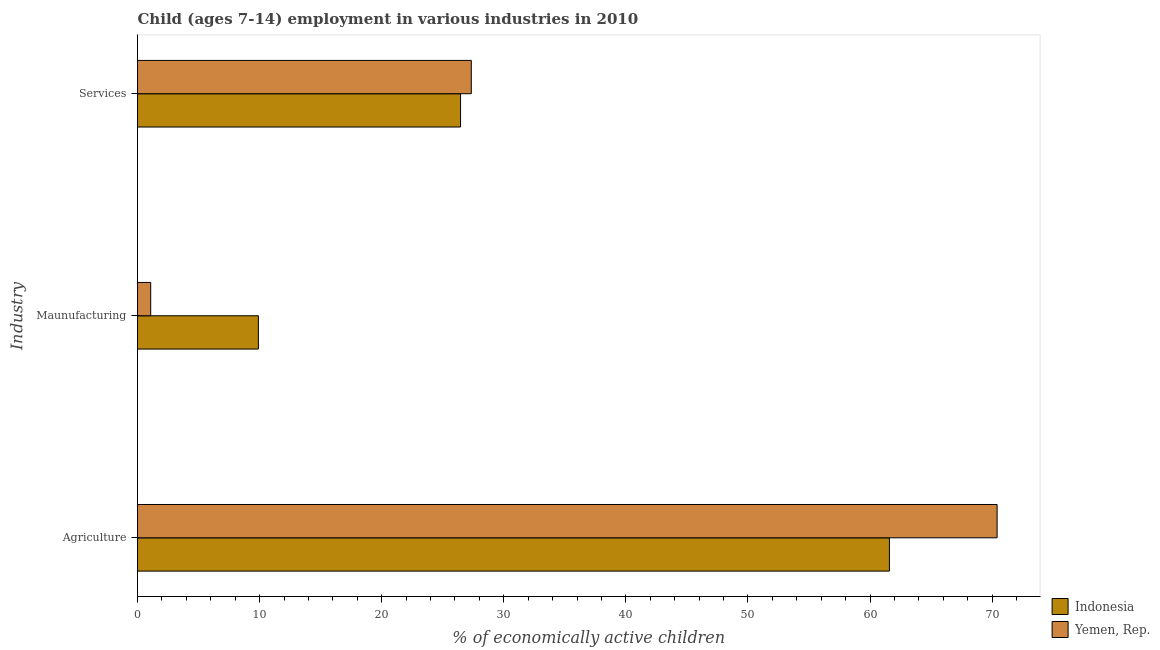How many different coloured bars are there?
Your answer should be compact. 2. How many groups of bars are there?
Provide a succinct answer. 3. Are the number of bars on each tick of the Y-axis equal?
Make the answer very short. Yes. How many bars are there on the 3rd tick from the bottom?
Provide a short and direct response. 2. What is the label of the 2nd group of bars from the top?
Offer a terse response. Maunufacturing. What is the percentage of economically active children in services in Yemen, Rep.?
Provide a succinct answer. 27.34. Across all countries, what is the maximum percentage of economically active children in agriculture?
Your answer should be compact. 70.41. Across all countries, what is the minimum percentage of economically active children in agriculture?
Make the answer very short. 61.59. In which country was the percentage of economically active children in manufacturing maximum?
Provide a short and direct response. Indonesia. In which country was the percentage of economically active children in agriculture minimum?
Give a very brief answer. Indonesia. What is the total percentage of economically active children in agriculture in the graph?
Make the answer very short. 132. What is the difference between the percentage of economically active children in agriculture in Yemen, Rep. and that in Indonesia?
Make the answer very short. 8.82. What is the difference between the percentage of economically active children in agriculture in Yemen, Rep. and the percentage of economically active children in manufacturing in Indonesia?
Ensure brevity in your answer.  60.51. What is the difference between the percentage of economically active children in manufacturing and percentage of economically active children in services in Indonesia?
Provide a succinct answer. -16.56. In how many countries, is the percentage of economically active children in agriculture greater than 4 %?
Offer a very short reply. 2. What is the ratio of the percentage of economically active children in agriculture in Indonesia to that in Yemen, Rep.?
Provide a succinct answer. 0.87. Is the percentage of economically active children in agriculture in Indonesia less than that in Yemen, Rep.?
Ensure brevity in your answer.  Yes. What is the difference between the highest and the second highest percentage of economically active children in agriculture?
Offer a terse response. 8.82. What is the difference between the highest and the lowest percentage of economically active children in agriculture?
Your answer should be compact. 8.82. In how many countries, is the percentage of economically active children in agriculture greater than the average percentage of economically active children in agriculture taken over all countries?
Make the answer very short. 1. What does the 2nd bar from the top in Agriculture represents?
Provide a short and direct response. Indonesia. What does the 2nd bar from the bottom in Agriculture represents?
Offer a terse response. Yemen, Rep. Is it the case that in every country, the sum of the percentage of economically active children in agriculture and percentage of economically active children in manufacturing is greater than the percentage of economically active children in services?
Make the answer very short. Yes. Are all the bars in the graph horizontal?
Offer a terse response. Yes. What is the difference between two consecutive major ticks on the X-axis?
Your response must be concise. 10. Are the values on the major ticks of X-axis written in scientific E-notation?
Your answer should be very brief. No. Does the graph contain grids?
Provide a short and direct response. No. Where does the legend appear in the graph?
Give a very brief answer. Bottom right. How many legend labels are there?
Your answer should be very brief. 2. How are the legend labels stacked?
Offer a very short reply. Vertical. What is the title of the graph?
Your answer should be compact. Child (ages 7-14) employment in various industries in 2010. Does "Northern Mariana Islands" appear as one of the legend labels in the graph?
Keep it short and to the point. No. What is the label or title of the X-axis?
Ensure brevity in your answer.  % of economically active children. What is the label or title of the Y-axis?
Your response must be concise. Industry. What is the % of economically active children of Indonesia in Agriculture?
Offer a very short reply. 61.59. What is the % of economically active children in Yemen, Rep. in Agriculture?
Offer a terse response. 70.41. What is the % of economically active children of Indonesia in Maunufacturing?
Offer a very short reply. 9.9. What is the % of economically active children of Indonesia in Services?
Make the answer very short. 26.46. What is the % of economically active children in Yemen, Rep. in Services?
Your answer should be compact. 27.34. Across all Industry, what is the maximum % of economically active children in Indonesia?
Give a very brief answer. 61.59. Across all Industry, what is the maximum % of economically active children in Yemen, Rep.?
Provide a short and direct response. 70.41. Across all Industry, what is the minimum % of economically active children in Indonesia?
Give a very brief answer. 9.9. Across all Industry, what is the minimum % of economically active children of Yemen, Rep.?
Provide a short and direct response. 1.08. What is the total % of economically active children of Indonesia in the graph?
Give a very brief answer. 97.95. What is the total % of economically active children in Yemen, Rep. in the graph?
Give a very brief answer. 98.83. What is the difference between the % of economically active children in Indonesia in Agriculture and that in Maunufacturing?
Provide a short and direct response. 51.69. What is the difference between the % of economically active children of Yemen, Rep. in Agriculture and that in Maunufacturing?
Provide a succinct answer. 69.33. What is the difference between the % of economically active children of Indonesia in Agriculture and that in Services?
Give a very brief answer. 35.13. What is the difference between the % of economically active children in Yemen, Rep. in Agriculture and that in Services?
Your answer should be very brief. 43.07. What is the difference between the % of economically active children in Indonesia in Maunufacturing and that in Services?
Keep it short and to the point. -16.56. What is the difference between the % of economically active children in Yemen, Rep. in Maunufacturing and that in Services?
Ensure brevity in your answer.  -26.26. What is the difference between the % of economically active children in Indonesia in Agriculture and the % of economically active children in Yemen, Rep. in Maunufacturing?
Keep it short and to the point. 60.51. What is the difference between the % of economically active children in Indonesia in Agriculture and the % of economically active children in Yemen, Rep. in Services?
Make the answer very short. 34.25. What is the difference between the % of economically active children of Indonesia in Maunufacturing and the % of economically active children of Yemen, Rep. in Services?
Offer a very short reply. -17.44. What is the average % of economically active children of Indonesia per Industry?
Provide a short and direct response. 32.65. What is the average % of economically active children in Yemen, Rep. per Industry?
Ensure brevity in your answer.  32.94. What is the difference between the % of economically active children in Indonesia and % of economically active children in Yemen, Rep. in Agriculture?
Make the answer very short. -8.82. What is the difference between the % of economically active children of Indonesia and % of economically active children of Yemen, Rep. in Maunufacturing?
Ensure brevity in your answer.  8.82. What is the difference between the % of economically active children of Indonesia and % of economically active children of Yemen, Rep. in Services?
Your answer should be very brief. -0.88. What is the ratio of the % of economically active children of Indonesia in Agriculture to that in Maunufacturing?
Keep it short and to the point. 6.22. What is the ratio of the % of economically active children of Yemen, Rep. in Agriculture to that in Maunufacturing?
Make the answer very short. 65.19. What is the ratio of the % of economically active children of Indonesia in Agriculture to that in Services?
Your response must be concise. 2.33. What is the ratio of the % of economically active children in Yemen, Rep. in Agriculture to that in Services?
Offer a terse response. 2.58. What is the ratio of the % of economically active children of Indonesia in Maunufacturing to that in Services?
Make the answer very short. 0.37. What is the ratio of the % of economically active children of Yemen, Rep. in Maunufacturing to that in Services?
Ensure brevity in your answer.  0.04. What is the difference between the highest and the second highest % of economically active children in Indonesia?
Your answer should be very brief. 35.13. What is the difference between the highest and the second highest % of economically active children of Yemen, Rep.?
Offer a terse response. 43.07. What is the difference between the highest and the lowest % of economically active children of Indonesia?
Give a very brief answer. 51.69. What is the difference between the highest and the lowest % of economically active children in Yemen, Rep.?
Provide a succinct answer. 69.33. 